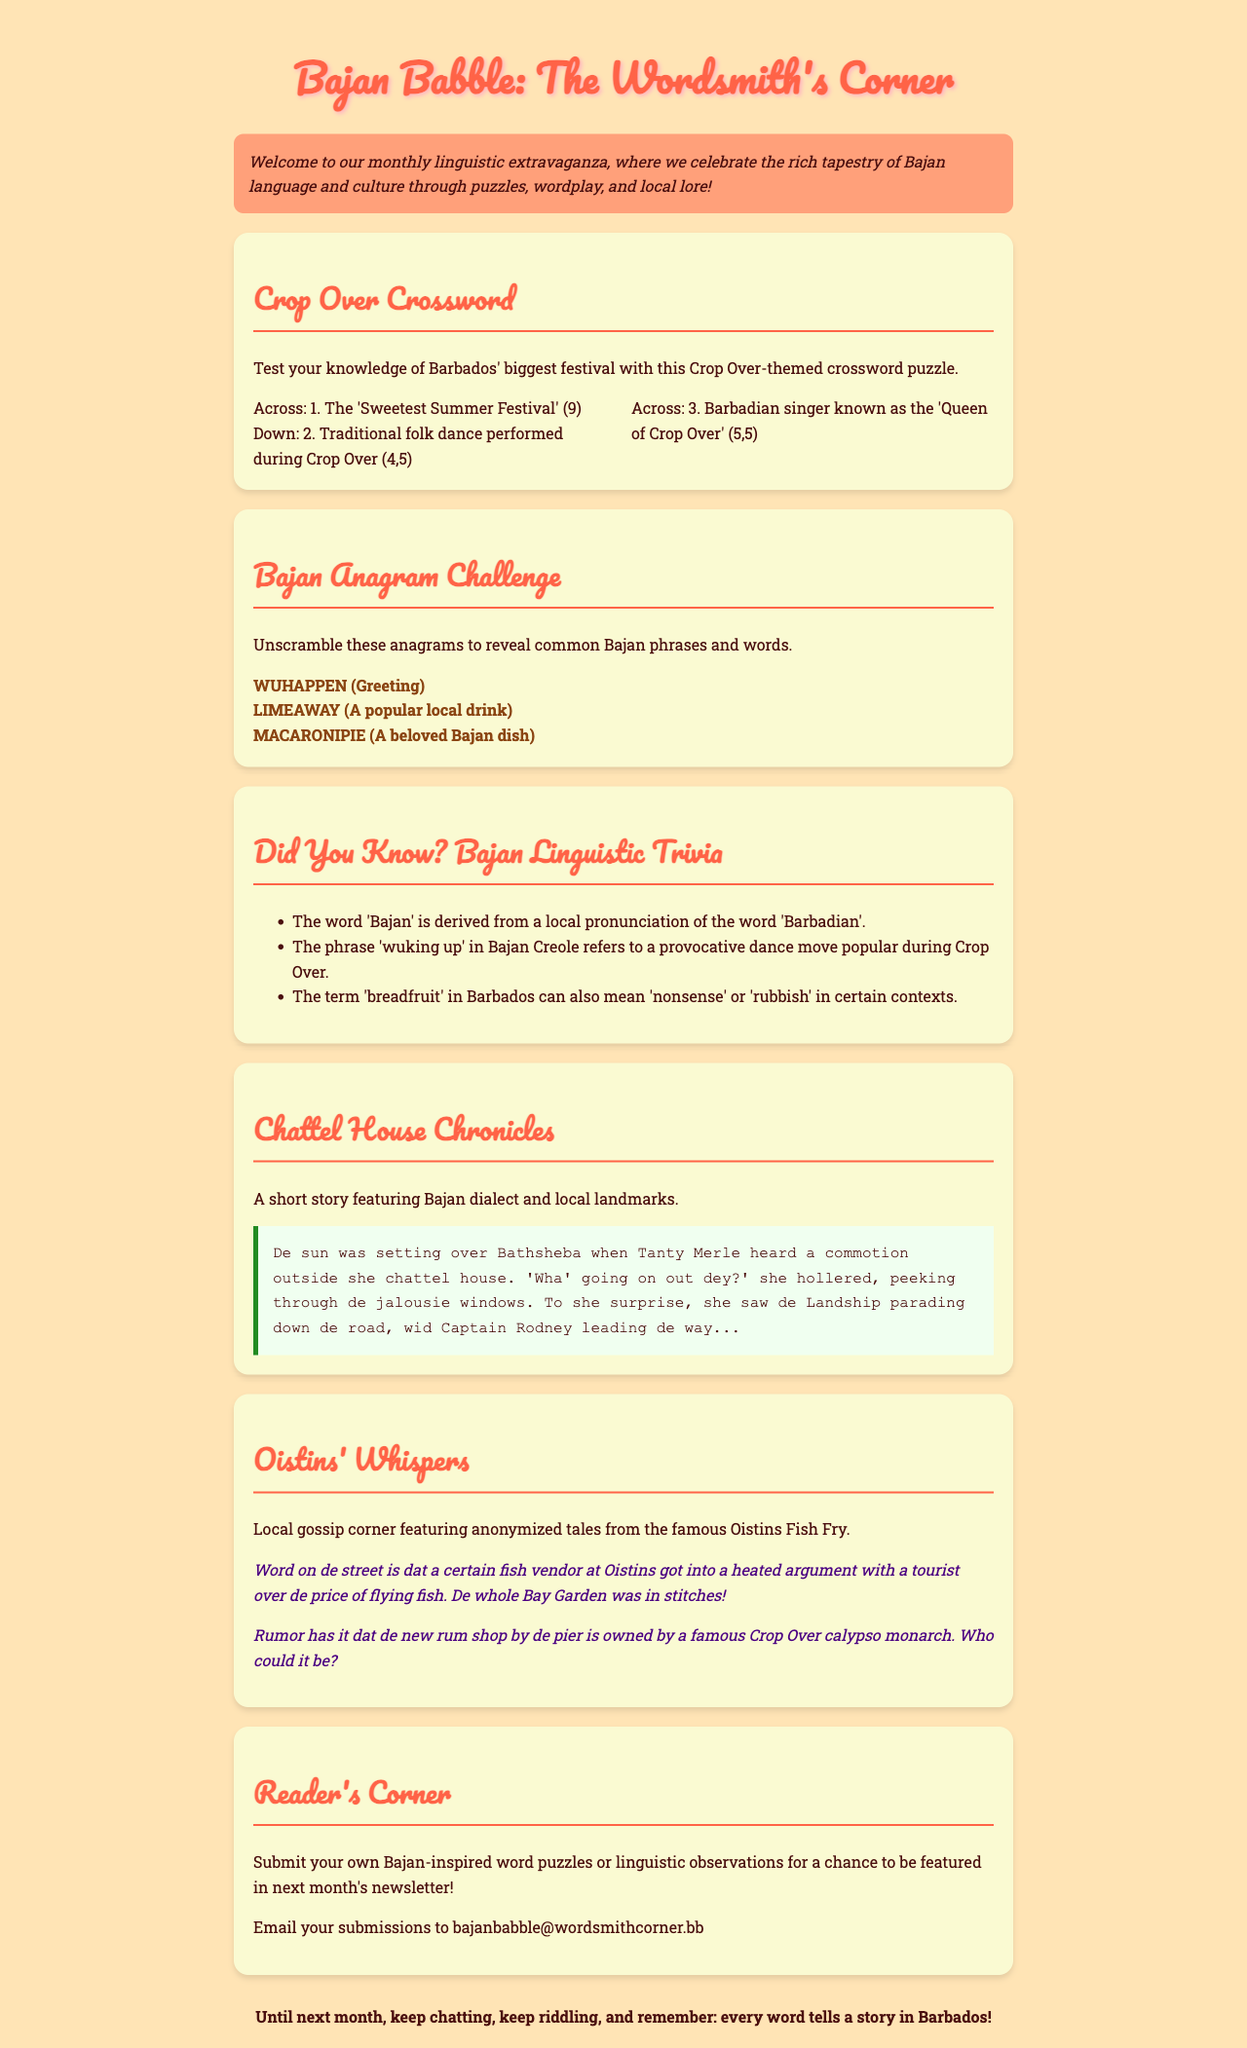What is the title of the newsletter? The title is located at the top of the document and introduces the main theme, which is "Bajan Babble: The Wordsmith's Corner."
Answer: Bajan Babble: The Wordsmith's Corner What festival is featured in the crossword puzzle? The crossword puzzle revolves around Barbados' largest festival, as indicated by the description of the "Crop Over Crossword" section.
Answer: Crop Over What is a popular local drink mentioned in the anagram challenge? The document lists "LIMEAWAY" as an anagram, which corresponds to a popular local drink.
Answer: Limeade What is the relationship between the term 'breadfruit' and its meaning in Barbados? The document states that "breadfruit" can mean both the fruit and also refer to 'nonsense' or 'rubbish' in certain contexts.
Answer: Nonsense Which Bajan singer is referred to as the 'Queen of Crop Over'? Clue 3 in the crossword puzzle directly mentions a Barbadian singer known by this title.
Answer: Alison Hinds Where was Tanty Merle's chattel house located? The story snippet describes a setting where Tanzy Merle's house is found, specifically mentioning "over Bathsheba."
Answer: Bathsheba What are readers encouraged to submit in the Reader's Corner? The section encourages readers to contribute their own items related to word puzzles or linguistic observations, emphasizing a participatory aspect.
Answer: Word puzzles What is the email address for submissions? The document provides a specific email address for readers' contributions to the newsletter, located in the Reader's Corner.
Answer: bajanbabble@wordsmithcorner.bb 